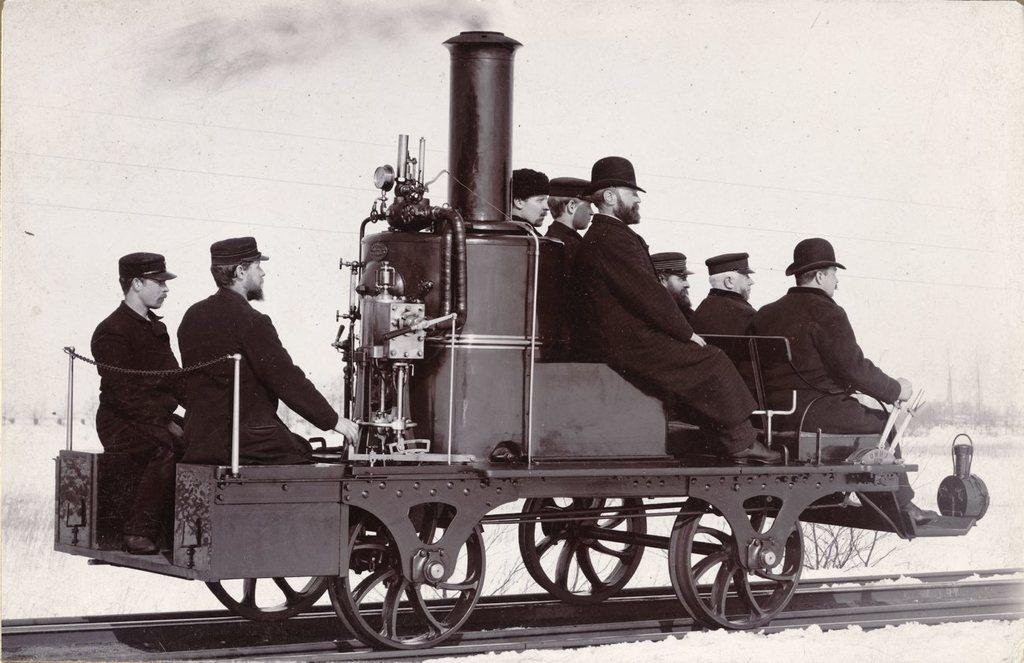What is the color scheme of the image? The image is black and white. What can be seen in the image? There is a group of people in the image. Where are the people sitting in the image? The people are sitting on a steam engine. What is the steam engine's location in the image? The steam engine is on a railway track. What is visible in the background of the image? The sky is visible in the background of the image. What type of toys are the people playing with on the steam engine? There are no toys present in the image; the people are sitting on a steam engine. Can you tell me how many goats are visible in the image? There are no goats present in the image; the main subjects are a group of people sitting on a steam engine. 